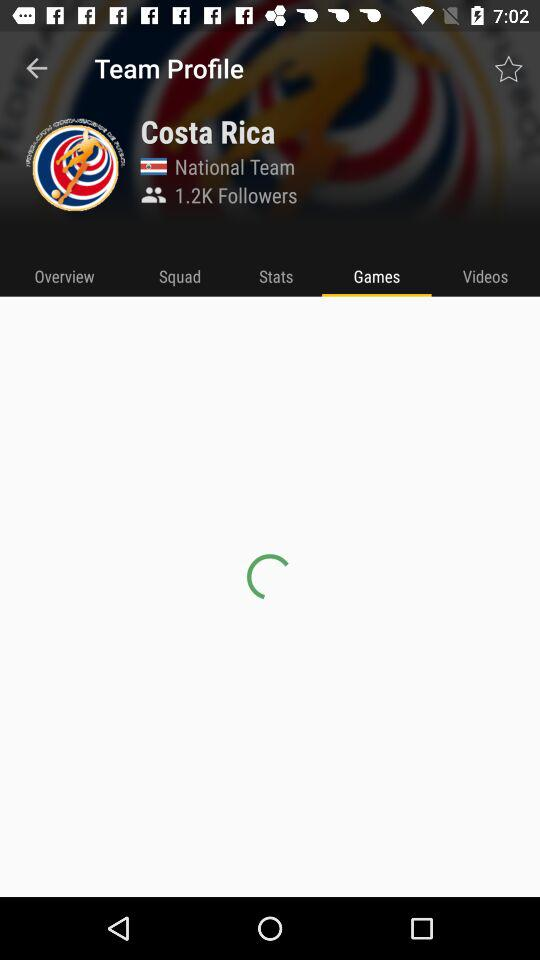Which tab is selected? The selected tab is "Games". 